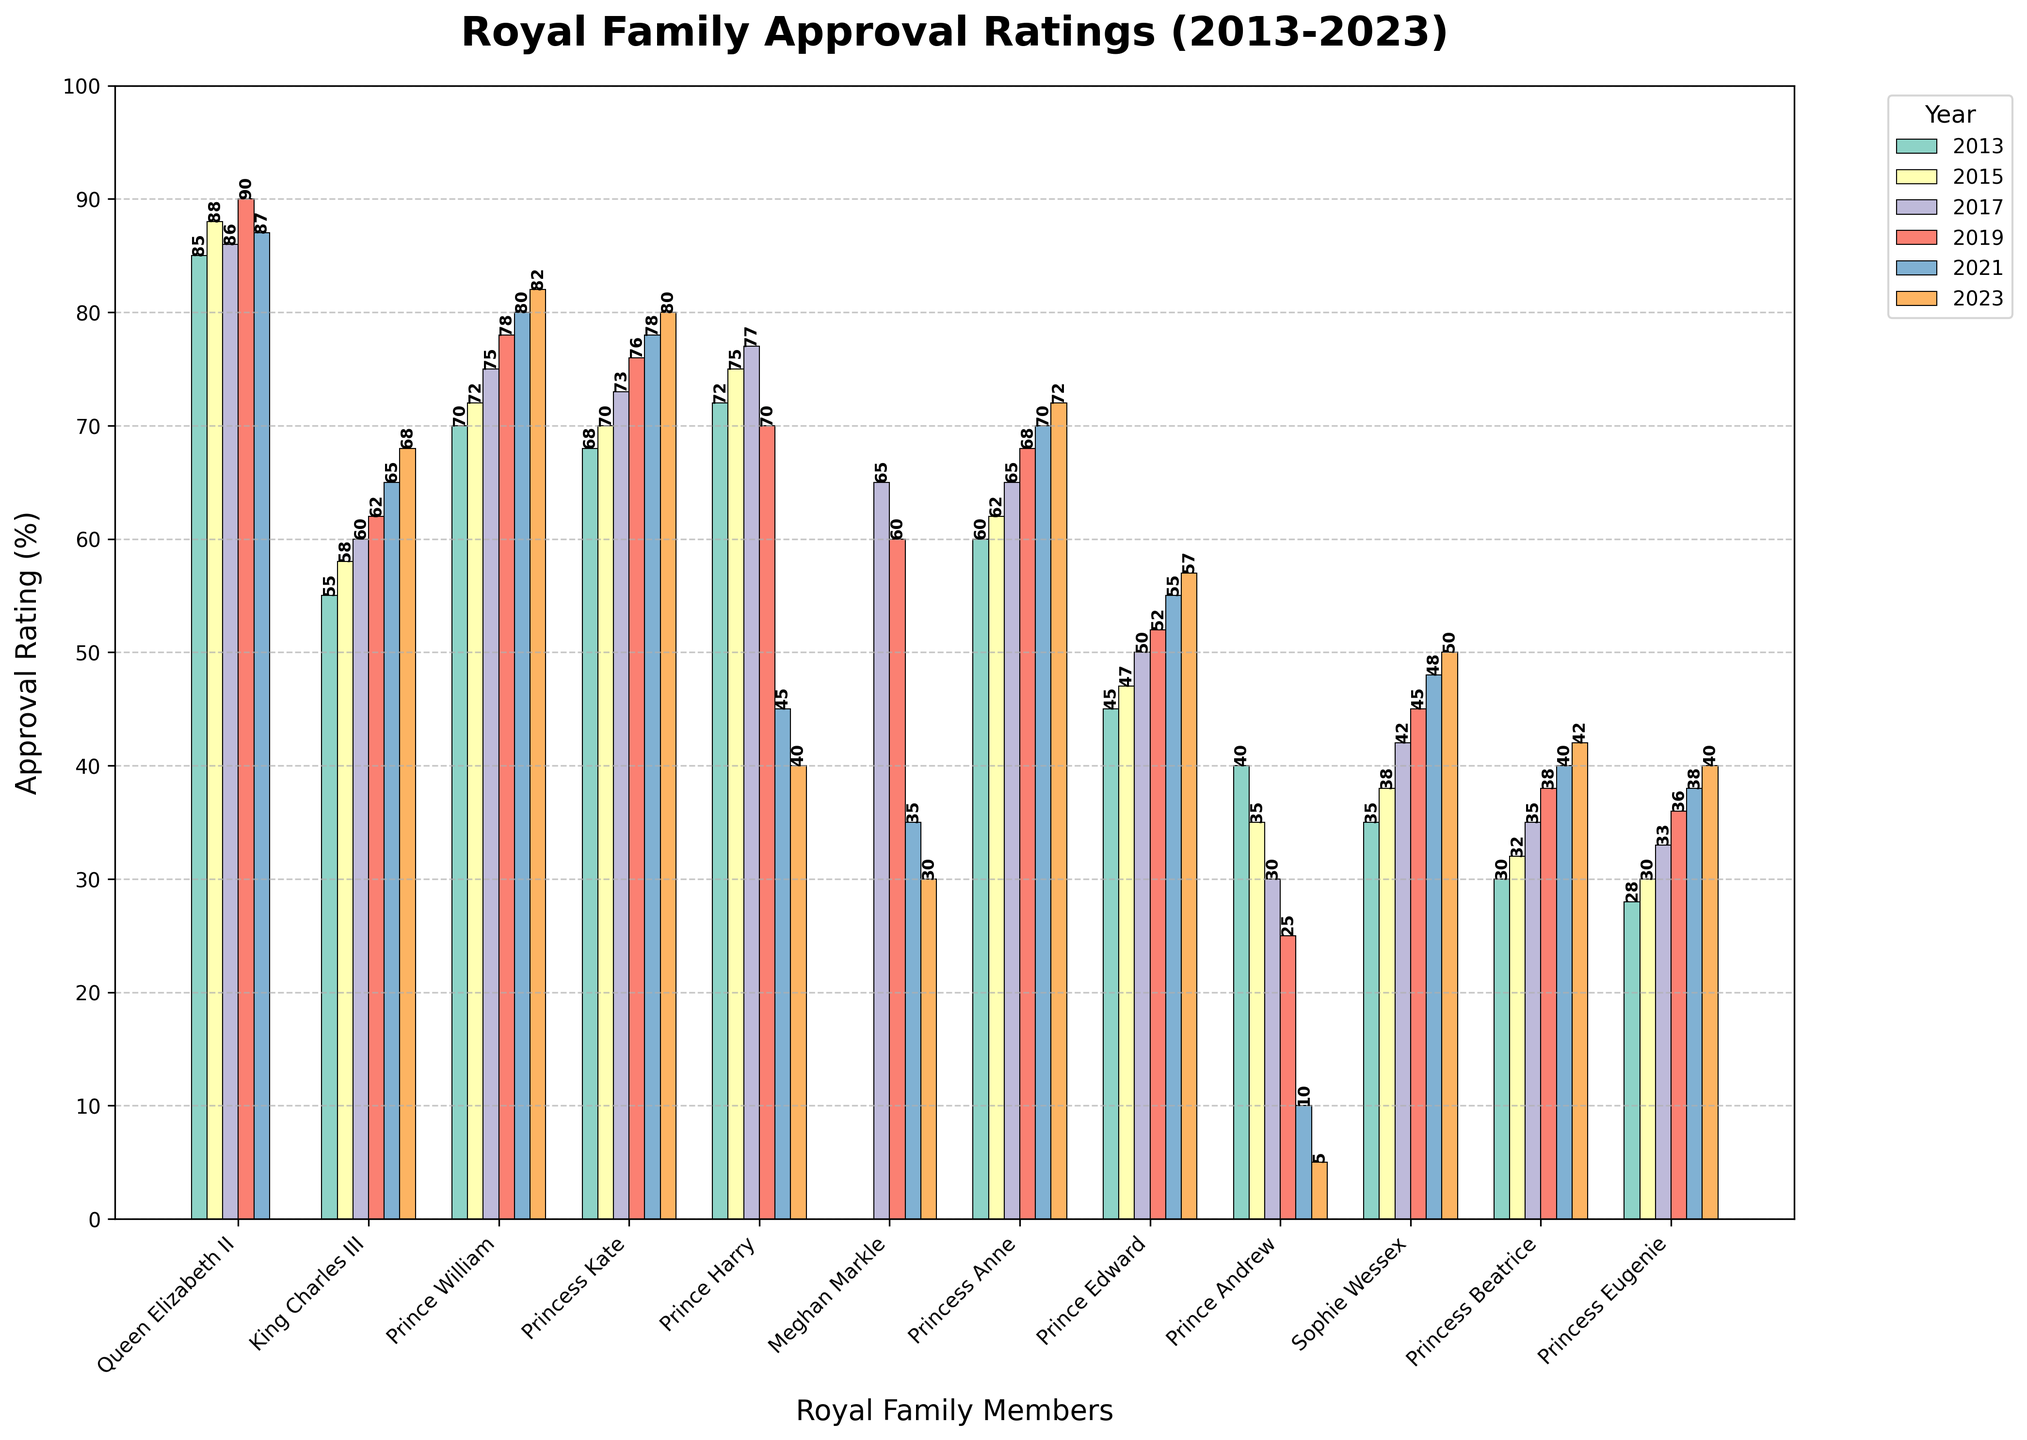Which royal family member had the highest approval rating in 2019? Look for the member with the tallest bar in the year 2019. The tallest bar corresponds to Queen Elizabeth II with a rating of 90.
Answer: Queen Elizabeth II Which royal family member's approval rating dropped the most between 2017 and 2023? Calculate the difference in approval ratings for each member between 2017 and 2023, noting the largest negative change. Prince Harry's rating decreased from 77 in 2017 to 40 in 2023, a drop of 37 points.
Answer: Prince Harry What was the average approval rating of Princess Anne over the decade? Sum the available ratings for Princess Anne and divide by the number of years: (60+62+65+68+70+72)/6 = 66.17.
Answer: 66.17 Comparing 2021, who had a higher approval rating, Prince William or King Charles III? Check the bars for both members in 2021. Prince William has a rating of 80, while King Charles III has a rating of 65.
Answer: Prince William Which member showed a steady increase in approval ratings every year from 2013 to 2023? Track the ratings for each member from 2013 to 2023 and identify the one with consistent increases. King Charles III has increased steadily from 55 in 2013 to 68 in 2023.
Answer: King Charles III In which year did Meghan Markle first appear in the approval rating data? Observe the list of years for Meghan Markle and identify the first year with a visible bar. Meghan Markle first appeared in 2017 with a rating of 65.
Answer: 2017 How did Prince Andrew's approval rating change in the decade? Compare Prince Andrew's rating from year to year: 40 (2013), 35 (2015), 30 (2017), 25 (2019), 10 (2021), 5 (2023). This is a continuous decline from 40 to 5.
Answer: Decreased What is the combined approval rating of the Queen Elizabeth II and Princess Kate in 2013? Add the ratings of Queen Elizabeth II and Princess Kate in 2013: 85 + 68 = 153.
Answer: 153 Who had a higher approval rating in 2023, Sophie Wessex or Prince Edward? Compare the 2023 bars for both members. Sophie Wessex has a rating of 50, while Prince Edward has 57.
Answer: Prince Edward Which year had the highest approval rating for Prince William? Examine Prince William's bars for every year and identify the tallest one. The tallest is in 2023 with a rating of 82.
Answer: 2023 